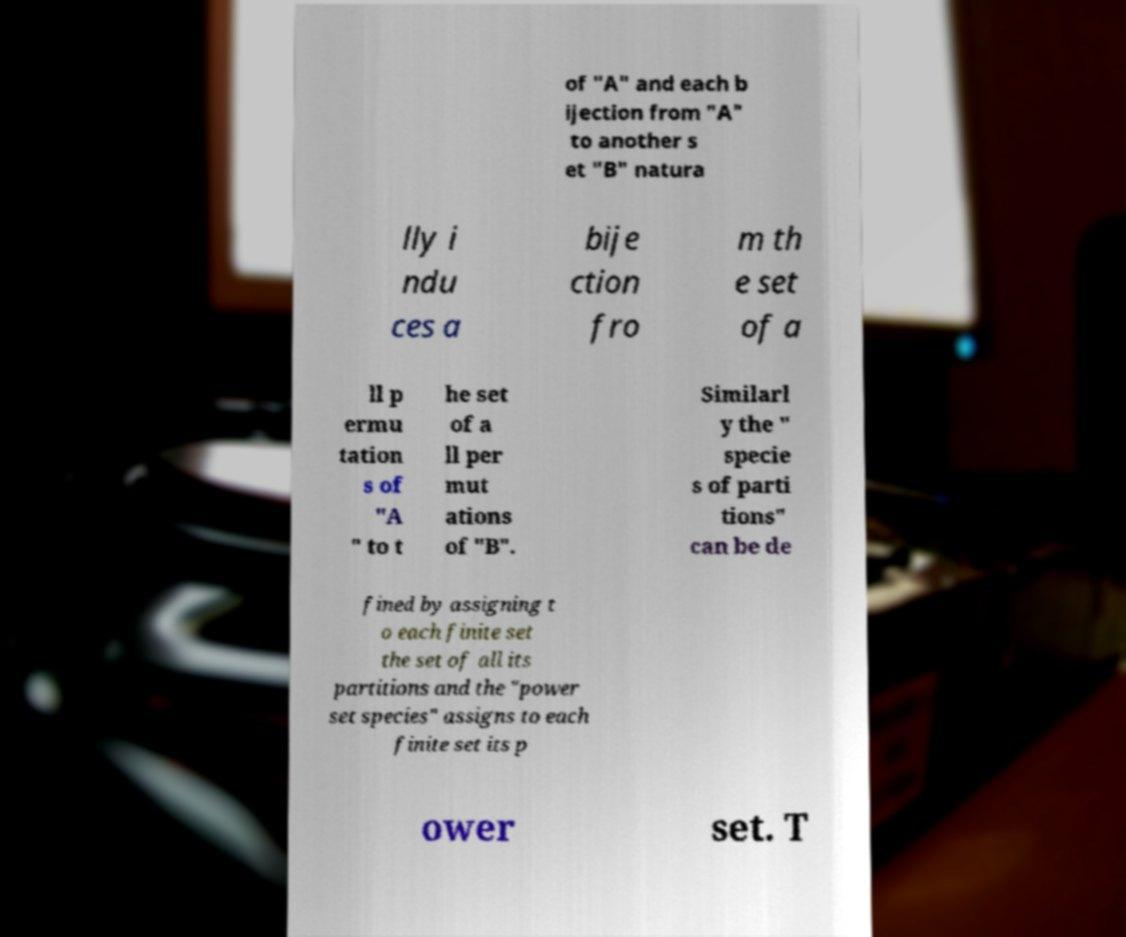For documentation purposes, I need the text within this image transcribed. Could you provide that? of "A" and each b ijection from "A" to another s et "B" natura lly i ndu ces a bije ction fro m th e set of a ll p ermu tation s of "A " to t he set of a ll per mut ations of "B". Similarl y the " specie s of parti tions" can be de fined by assigning t o each finite set the set of all its partitions and the "power set species" assigns to each finite set its p ower set. T 